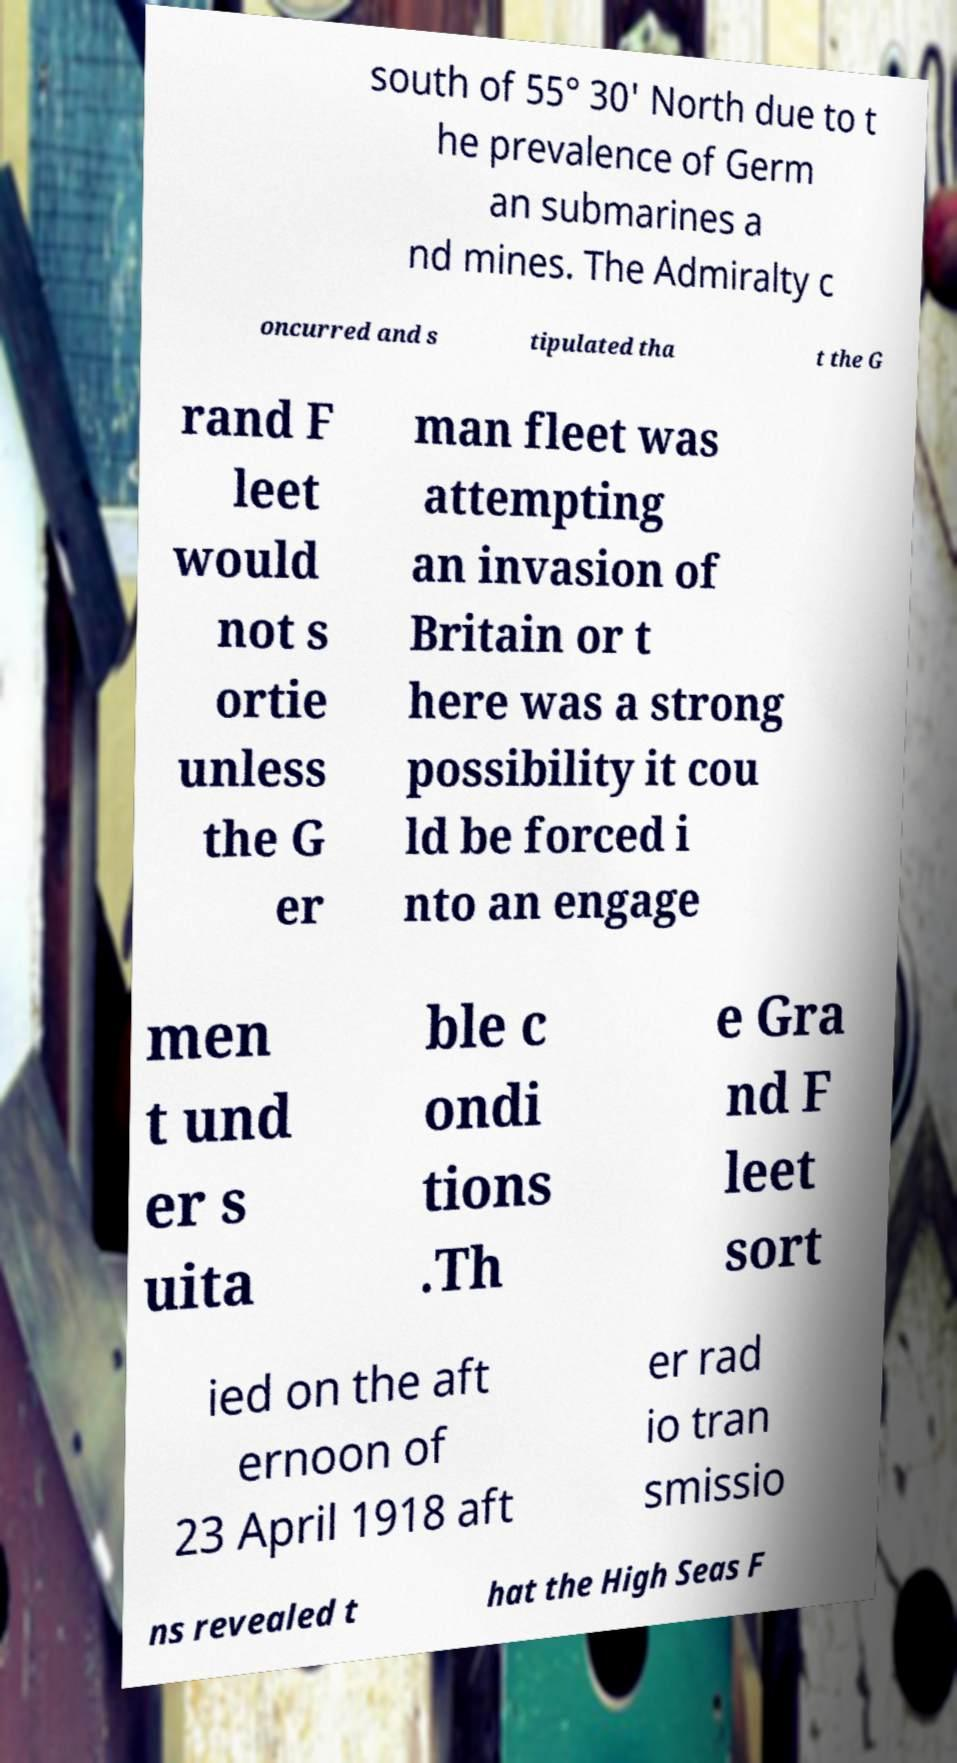I need the written content from this picture converted into text. Can you do that? south of 55° 30' North due to t he prevalence of Germ an submarines a nd mines. The Admiralty c oncurred and s tipulated tha t the G rand F leet would not s ortie unless the G er man fleet was attempting an invasion of Britain or t here was a strong possibility it cou ld be forced i nto an engage men t und er s uita ble c ondi tions .Th e Gra nd F leet sort ied on the aft ernoon of 23 April 1918 aft er rad io tran smissio ns revealed t hat the High Seas F 